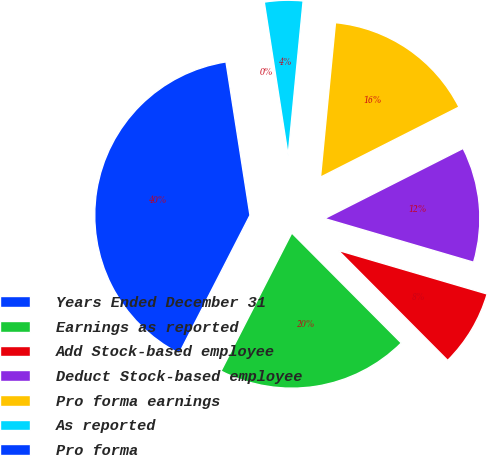Convert chart to OTSL. <chart><loc_0><loc_0><loc_500><loc_500><pie_chart><fcel>Years Ended December 31<fcel>Earnings as reported<fcel>Add Stock-based employee<fcel>Deduct Stock-based employee<fcel>Pro forma earnings<fcel>As reported<fcel>Pro forma<nl><fcel>39.99%<fcel>20.0%<fcel>8.0%<fcel>12.0%<fcel>16.0%<fcel>4.0%<fcel>0.01%<nl></chart> 